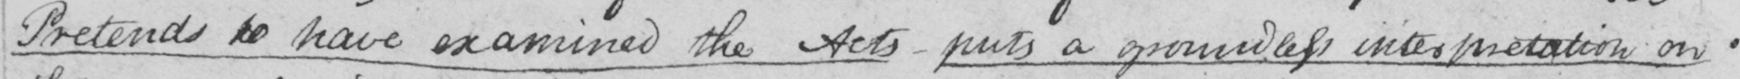Please transcribe the handwritten text in this image. Pretends to have examined the Acts  _  puts a groundless interpretation on 